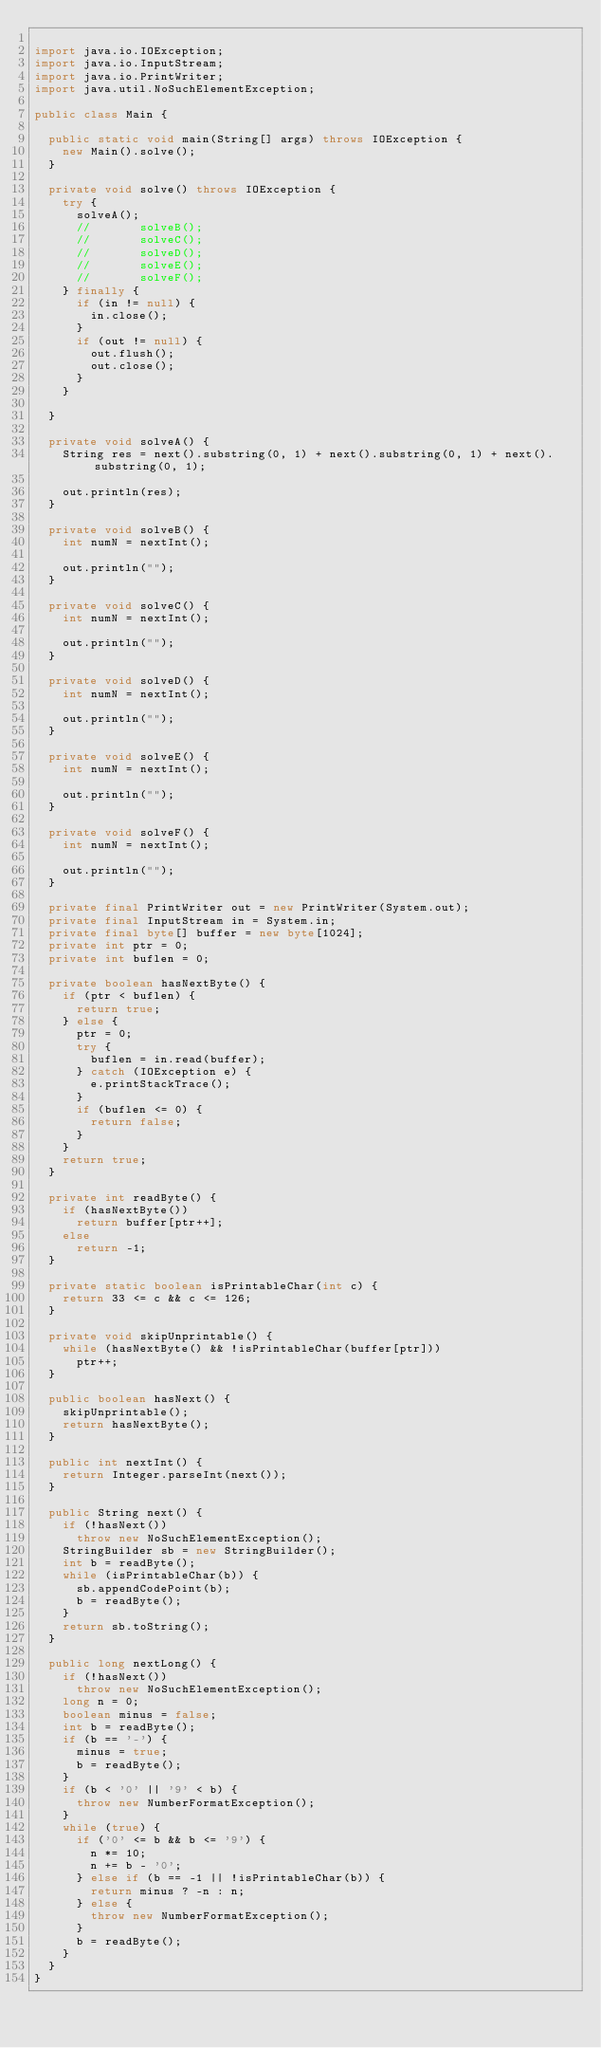Convert code to text. <code><loc_0><loc_0><loc_500><loc_500><_Java_>
import java.io.IOException;
import java.io.InputStream;
import java.io.PrintWriter;
import java.util.NoSuchElementException;

public class Main {

	public static void main(String[] args) throws IOException {
		new Main().solve();
	}

	private void solve() throws IOException {
		try {
			solveA();
			//			 solveB();
			//			 solveC();
			//			 solveD();
			//			 solveE();
			//			 solveF();
		} finally {
			if (in != null) {
				in.close();
			}
			if (out != null) {
				out.flush();
				out.close();
			}
		}

	}

	private void solveA() {
		String res = next().substring(0, 1) + next().substring(0, 1) + next().substring(0, 1);

		out.println(res);
	}

	private void solveB() {
		int numN = nextInt();

		out.println("");
	}

	private void solveC() {
		int numN = nextInt();

		out.println("");
	}

	private void solveD() {
		int numN = nextInt();

		out.println("");
	}

	private void solveE() {
		int numN = nextInt();

		out.println("");
	}

	private void solveF() {
		int numN = nextInt();

		out.println("");
	}

	private final PrintWriter out = new PrintWriter(System.out);
	private final InputStream in = System.in;
	private final byte[] buffer = new byte[1024];
	private int ptr = 0;
	private int buflen = 0;

	private boolean hasNextByte() {
		if (ptr < buflen) {
			return true;
		} else {
			ptr = 0;
			try {
				buflen = in.read(buffer);
			} catch (IOException e) {
				e.printStackTrace();
			}
			if (buflen <= 0) {
				return false;
			}
		}
		return true;
	}

	private int readByte() {
		if (hasNextByte())
			return buffer[ptr++];
		else
			return -1;
	}

	private static boolean isPrintableChar(int c) {
		return 33 <= c && c <= 126;
	}

	private void skipUnprintable() {
		while (hasNextByte() && !isPrintableChar(buffer[ptr]))
			ptr++;
	}

	public boolean hasNext() {
		skipUnprintable();
		return hasNextByte();
	}

	public int nextInt() {
		return Integer.parseInt(next());
	}

	public String next() {
		if (!hasNext())
			throw new NoSuchElementException();
		StringBuilder sb = new StringBuilder();
		int b = readByte();
		while (isPrintableChar(b)) {
			sb.appendCodePoint(b);
			b = readByte();
		}
		return sb.toString();
	}

	public long nextLong() {
		if (!hasNext())
			throw new NoSuchElementException();
		long n = 0;
		boolean minus = false;
		int b = readByte();
		if (b == '-') {
			minus = true;
			b = readByte();
		}
		if (b < '0' || '9' < b) {
			throw new NumberFormatException();
		}
		while (true) {
			if ('0' <= b && b <= '9') {
				n *= 10;
				n += b - '0';
			} else if (b == -1 || !isPrintableChar(b)) {
				return minus ? -n : n;
			} else {
				throw new NumberFormatException();
			}
			b = readByte();
		}
	}
}</code> 